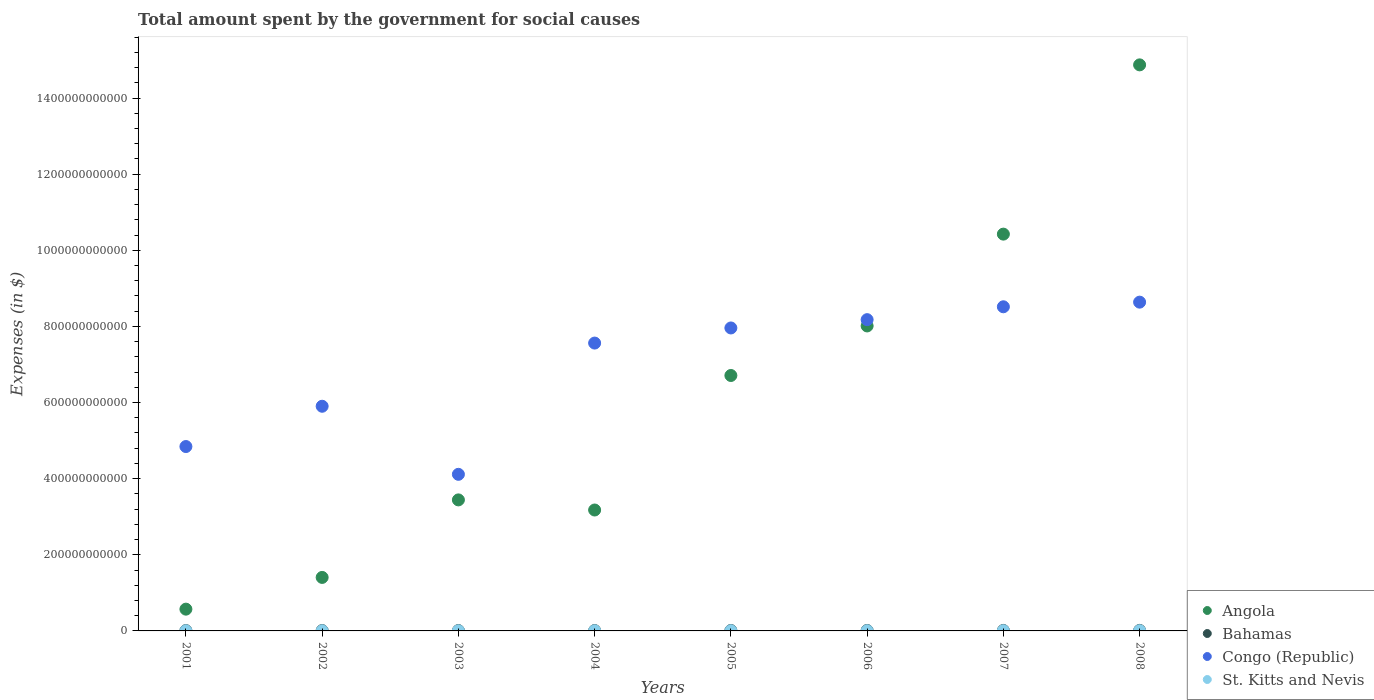Is the number of dotlines equal to the number of legend labels?
Give a very brief answer. Yes. What is the amount spent for social causes by the government in Congo (Republic) in 2007?
Make the answer very short. 8.52e+11. Across all years, what is the maximum amount spent for social causes by the government in St. Kitts and Nevis?
Offer a terse response. 5.36e+08. Across all years, what is the minimum amount spent for social causes by the government in St. Kitts and Nevis?
Your response must be concise. 3.07e+08. What is the total amount spent for social causes by the government in Angola in the graph?
Your response must be concise. 4.86e+12. What is the difference between the amount spent for social causes by the government in St. Kitts and Nevis in 2007 and that in 2008?
Your answer should be very brief. -3.61e+07. What is the difference between the amount spent for social causes by the government in Congo (Republic) in 2007 and the amount spent for social causes by the government in Bahamas in 2008?
Your response must be concise. 8.50e+11. What is the average amount spent for social causes by the government in Bahamas per year?
Your response must be concise. 1.09e+09. In the year 2001, what is the difference between the amount spent for social causes by the government in St. Kitts and Nevis and amount spent for social causes by the government in Congo (Republic)?
Offer a very short reply. -4.84e+11. In how many years, is the amount spent for social causes by the government in Angola greater than 880000000000 $?
Provide a succinct answer. 2. What is the ratio of the amount spent for social causes by the government in Bahamas in 2004 to that in 2007?
Provide a succinct answer. 0.81. Is the amount spent for social causes by the government in Angola in 2001 less than that in 2004?
Your response must be concise. Yes. Is the difference between the amount spent for social causes by the government in St. Kitts and Nevis in 2003 and 2004 greater than the difference between the amount spent for social causes by the government in Congo (Republic) in 2003 and 2004?
Make the answer very short. Yes. What is the difference between the highest and the second highest amount spent for social causes by the government in Angola?
Ensure brevity in your answer.  4.45e+11. What is the difference between the highest and the lowest amount spent for social causes by the government in St. Kitts and Nevis?
Your answer should be compact. 2.29e+08. In how many years, is the amount spent for social causes by the government in St. Kitts and Nevis greater than the average amount spent for social causes by the government in St. Kitts and Nevis taken over all years?
Ensure brevity in your answer.  4. Is the sum of the amount spent for social causes by the government in Bahamas in 2005 and 2006 greater than the maximum amount spent for social causes by the government in Congo (Republic) across all years?
Offer a very short reply. No. Is it the case that in every year, the sum of the amount spent for social causes by the government in Angola and amount spent for social causes by the government in Bahamas  is greater than the sum of amount spent for social causes by the government in Congo (Republic) and amount spent for social causes by the government in St. Kitts and Nevis?
Your answer should be compact. No. Is it the case that in every year, the sum of the amount spent for social causes by the government in St. Kitts and Nevis and amount spent for social causes by the government in Angola  is greater than the amount spent for social causes by the government in Congo (Republic)?
Give a very brief answer. No. Does the amount spent for social causes by the government in Bahamas monotonically increase over the years?
Offer a terse response. Yes. Is the amount spent for social causes by the government in Bahamas strictly greater than the amount spent for social causes by the government in Angola over the years?
Keep it short and to the point. No. How many dotlines are there?
Your response must be concise. 4. What is the difference between two consecutive major ticks on the Y-axis?
Provide a succinct answer. 2.00e+11. Does the graph contain any zero values?
Ensure brevity in your answer.  No. Where does the legend appear in the graph?
Your response must be concise. Bottom right. How many legend labels are there?
Provide a succinct answer. 4. What is the title of the graph?
Offer a very short reply. Total amount spent by the government for social causes. What is the label or title of the Y-axis?
Your answer should be very brief. Expenses (in $). What is the Expenses (in $) in Angola in 2001?
Your response must be concise. 5.72e+1. What is the Expenses (in $) of Bahamas in 2001?
Keep it short and to the point. 8.67e+08. What is the Expenses (in $) of Congo (Republic) in 2001?
Provide a short and direct response. 4.84e+11. What is the Expenses (in $) in St. Kitts and Nevis in 2001?
Your answer should be compact. 3.07e+08. What is the Expenses (in $) in Angola in 2002?
Ensure brevity in your answer.  1.41e+11. What is the Expenses (in $) in Bahamas in 2002?
Provide a succinct answer. 9.23e+08. What is the Expenses (in $) in Congo (Republic) in 2002?
Your response must be concise. 5.90e+11. What is the Expenses (in $) in St. Kitts and Nevis in 2002?
Provide a short and direct response. 3.24e+08. What is the Expenses (in $) in Angola in 2003?
Make the answer very short. 3.44e+11. What is the Expenses (in $) in Bahamas in 2003?
Give a very brief answer. 9.99e+08. What is the Expenses (in $) in Congo (Republic) in 2003?
Your response must be concise. 4.11e+11. What is the Expenses (in $) in St. Kitts and Nevis in 2003?
Your response must be concise. 3.33e+08. What is the Expenses (in $) in Angola in 2004?
Make the answer very short. 3.18e+11. What is the Expenses (in $) of Bahamas in 2004?
Offer a very short reply. 1.02e+09. What is the Expenses (in $) of Congo (Republic) in 2004?
Provide a short and direct response. 7.56e+11. What is the Expenses (in $) in St. Kitts and Nevis in 2004?
Provide a short and direct response. 3.82e+08. What is the Expenses (in $) in Angola in 2005?
Offer a terse response. 6.71e+11. What is the Expenses (in $) in Bahamas in 2005?
Offer a terse response. 1.12e+09. What is the Expenses (in $) of Congo (Republic) in 2005?
Your answer should be very brief. 7.96e+11. What is the Expenses (in $) in St. Kitts and Nevis in 2005?
Give a very brief answer. 4.40e+08. What is the Expenses (in $) of Angola in 2006?
Your answer should be very brief. 8.01e+11. What is the Expenses (in $) of Bahamas in 2006?
Provide a succinct answer. 1.19e+09. What is the Expenses (in $) of Congo (Republic) in 2006?
Your response must be concise. 8.18e+11. What is the Expenses (in $) of St. Kitts and Nevis in 2006?
Offer a very short reply. 4.78e+08. What is the Expenses (in $) in Angola in 2007?
Offer a terse response. 1.04e+12. What is the Expenses (in $) of Bahamas in 2007?
Your answer should be compact. 1.26e+09. What is the Expenses (in $) of Congo (Republic) in 2007?
Make the answer very short. 8.52e+11. What is the Expenses (in $) of St. Kitts and Nevis in 2007?
Give a very brief answer. 5.00e+08. What is the Expenses (in $) of Angola in 2008?
Offer a terse response. 1.49e+12. What is the Expenses (in $) in Bahamas in 2008?
Provide a succinct answer. 1.34e+09. What is the Expenses (in $) in Congo (Republic) in 2008?
Make the answer very short. 8.64e+11. What is the Expenses (in $) in St. Kitts and Nevis in 2008?
Your answer should be compact. 5.36e+08. Across all years, what is the maximum Expenses (in $) in Angola?
Offer a terse response. 1.49e+12. Across all years, what is the maximum Expenses (in $) of Bahamas?
Provide a succinct answer. 1.34e+09. Across all years, what is the maximum Expenses (in $) in Congo (Republic)?
Ensure brevity in your answer.  8.64e+11. Across all years, what is the maximum Expenses (in $) of St. Kitts and Nevis?
Your response must be concise. 5.36e+08. Across all years, what is the minimum Expenses (in $) of Angola?
Ensure brevity in your answer.  5.72e+1. Across all years, what is the minimum Expenses (in $) in Bahamas?
Ensure brevity in your answer.  8.67e+08. Across all years, what is the minimum Expenses (in $) of Congo (Republic)?
Provide a succinct answer. 4.11e+11. Across all years, what is the minimum Expenses (in $) of St. Kitts and Nevis?
Your answer should be very brief. 3.07e+08. What is the total Expenses (in $) of Angola in the graph?
Your response must be concise. 4.86e+12. What is the total Expenses (in $) in Bahamas in the graph?
Your answer should be very brief. 8.72e+09. What is the total Expenses (in $) in Congo (Republic) in the graph?
Your response must be concise. 5.57e+12. What is the total Expenses (in $) in St. Kitts and Nevis in the graph?
Keep it short and to the point. 3.30e+09. What is the difference between the Expenses (in $) of Angola in 2001 and that in 2002?
Provide a succinct answer. -8.34e+1. What is the difference between the Expenses (in $) in Bahamas in 2001 and that in 2002?
Provide a short and direct response. -5.57e+07. What is the difference between the Expenses (in $) in Congo (Republic) in 2001 and that in 2002?
Your answer should be very brief. -1.06e+11. What is the difference between the Expenses (in $) in St. Kitts and Nevis in 2001 and that in 2002?
Ensure brevity in your answer.  -1.65e+07. What is the difference between the Expenses (in $) of Angola in 2001 and that in 2003?
Provide a succinct answer. -2.87e+11. What is the difference between the Expenses (in $) of Bahamas in 2001 and that in 2003?
Your answer should be compact. -1.32e+08. What is the difference between the Expenses (in $) in Congo (Republic) in 2001 and that in 2003?
Make the answer very short. 7.30e+1. What is the difference between the Expenses (in $) in St. Kitts and Nevis in 2001 and that in 2003?
Offer a very short reply. -2.61e+07. What is the difference between the Expenses (in $) in Angola in 2001 and that in 2004?
Your answer should be compact. -2.60e+11. What is the difference between the Expenses (in $) in Bahamas in 2001 and that in 2004?
Give a very brief answer. -1.54e+08. What is the difference between the Expenses (in $) in Congo (Republic) in 2001 and that in 2004?
Ensure brevity in your answer.  -2.72e+11. What is the difference between the Expenses (in $) of St. Kitts and Nevis in 2001 and that in 2004?
Keep it short and to the point. -7.45e+07. What is the difference between the Expenses (in $) of Angola in 2001 and that in 2005?
Offer a very short reply. -6.14e+11. What is the difference between the Expenses (in $) in Bahamas in 2001 and that in 2005?
Your response must be concise. -2.50e+08. What is the difference between the Expenses (in $) of Congo (Republic) in 2001 and that in 2005?
Offer a terse response. -3.12e+11. What is the difference between the Expenses (in $) of St. Kitts and Nevis in 2001 and that in 2005?
Ensure brevity in your answer.  -1.33e+08. What is the difference between the Expenses (in $) of Angola in 2001 and that in 2006?
Keep it short and to the point. -7.44e+11. What is the difference between the Expenses (in $) of Bahamas in 2001 and that in 2006?
Your answer should be very brief. -3.19e+08. What is the difference between the Expenses (in $) in Congo (Republic) in 2001 and that in 2006?
Make the answer very short. -3.33e+11. What is the difference between the Expenses (in $) in St. Kitts and Nevis in 2001 and that in 2006?
Offer a terse response. -1.71e+08. What is the difference between the Expenses (in $) in Angola in 2001 and that in 2007?
Ensure brevity in your answer.  -9.85e+11. What is the difference between the Expenses (in $) of Bahamas in 2001 and that in 2007?
Your response must be concise. -3.93e+08. What is the difference between the Expenses (in $) of Congo (Republic) in 2001 and that in 2007?
Your answer should be very brief. -3.67e+11. What is the difference between the Expenses (in $) of St. Kitts and Nevis in 2001 and that in 2007?
Offer a terse response. -1.93e+08. What is the difference between the Expenses (in $) of Angola in 2001 and that in 2008?
Keep it short and to the point. -1.43e+12. What is the difference between the Expenses (in $) in Bahamas in 2001 and that in 2008?
Give a very brief answer. -4.78e+08. What is the difference between the Expenses (in $) of Congo (Republic) in 2001 and that in 2008?
Offer a terse response. -3.79e+11. What is the difference between the Expenses (in $) of St. Kitts and Nevis in 2001 and that in 2008?
Provide a short and direct response. -2.29e+08. What is the difference between the Expenses (in $) of Angola in 2002 and that in 2003?
Ensure brevity in your answer.  -2.04e+11. What is the difference between the Expenses (in $) of Bahamas in 2002 and that in 2003?
Your answer should be compact. -7.63e+07. What is the difference between the Expenses (in $) in Congo (Republic) in 2002 and that in 2003?
Provide a succinct answer. 1.79e+11. What is the difference between the Expenses (in $) in St. Kitts and Nevis in 2002 and that in 2003?
Give a very brief answer. -9.60e+06. What is the difference between the Expenses (in $) of Angola in 2002 and that in 2004?
Offer a very short reply. -1.77e+11. What is the difference between the Expenses (in $) in Bahamas in 2002 and that in 2004?
Offer a terse response. -9.86e+07. What is the difference between the Expenses (in $) of Congo (Republic) in 2002 and that in 2004?
Provide a short and direct response. -1.66e+11. What is the difference between the Expenses (in $) of St. Kitts and Nevis in 2002 and that in 2004?
Provide a succinct answer. -5.80e+07. What is the difference between the Expenses (in $) of Angola in 2002 and that in 2005?
Offer a terse response. -5.31e+11. What is the difference between the Expenses (in $) of Bahamas in 2002 and that in 2005?
Offer a terse response. -1.94e+08. What is the difference between the Expenses (in $) of Congo (Republic) in 2002 and that in 2005?
Your answer should be very brief. -2.06e+11. What is the difference between the Expenses (in $) of St. Kitts and Nevis in 2002 and that in 2005?
Keep it short and to the point. -1.16e+08. What is the difference between the Expenses (in $) in Angola in 2002 and that in 2006?
Keep it short and to the point. -6.61e+11. What is the difference between the Expenses (in $) in Bahamas in 2002 and that in 2006?
Your answer should be compact. -2.63e+08. What is the difference between the Expenses (in $) of Congo (Republic) in 2002 and that in 2006?
Provide a succinct answer. -2.28e+11. What is the difference between the Expenses (in $) in St. Kitts and Nevis in 2002 and that in 2006?
Offer a terse response. -1.55e+08. What is the difference between the Expenses (in $) in Angola in 2002 and that in 2007?
Keep it short and to the point. -9.02e+11. What is the difference between the Expenses (in $) in Bahamas in 2002 and that in 2007?
Offer a very short reply. -3.37e+08. What is the difference between the Expenses (in $) in Congo (Republic) in 2002 and that in 2007?
Ensure brevity in your answer.  -2.61e+11. What is the difference between the Expenses (in $) in St. Kitts and Nevis in 2002 and that in 2007?
Provide a short and direct response. -1.77e+08. What is the difference between the Expenses (in $) in Angola in 2002 and that in 2008?
Your answer should be very brief. -1.35e+12. What is the difference between the Expenses (in $) in Bahamas in 2002 and that in 2008?
Your answer should be compact. -4.22e+08. What is the difference between the Expenses (in $) in Congo (Republic) in 2002 and that in 2008?
Provide a short and direct response. -2.74e+11. What is the difference between the Expenses (in $) in St. Kitts and Nevis in 2002 and that in 2008?
Offer a terse response. -2.13e+08. What is the difference between the Expenses (in $) of Angola in 2003 and that in 2004?
Your answer should be compact. 2.66e+1. What is the difference between the Expenses (in $) of Bahamas in 2003 and that in 2004?
Ensure brevity in your answer.  -2.23e+07. What is the difference between the Expenses (in $) in Congo (Republic) in 2003 and that in 2004?
Your answer should be very brief. -3.45e+11. What is the difference between the Expenses (in $) of St. Kitts and Nevis in 2003 and that in 2004?
Ensure brevity in your answer.  -4.84e+07. What is the difference between the Expenses (in $) of Angola in 2003 and that in 2005?
Provide a succinct answer. -3.27e+11. What is the difference between the Expenses (in $) in Bahamas in 2003 and that in 2005?
Offer a terse response. -1.18e+08. What is the difference between the Expenses (in $) of Congo (Republic) in 2003 and that in 2005?
Your answer should be very brief. -3.85e+11. What is the difference between the Expenses (in $) of St. Kitts and Nevis in 2003 and that in 2005?
Ensure brevity in your answer.  -1.07e+08. What is the difference between the Expenses (in $) in Angola in 2003 and that in 2006?
Provide a succinct answer. -4.57e+11. What is the difference between the Expenses (in $) of Bahamas in 2003 and that in 2006?
Provide a succinct answer. -1.87e+08. What is the difference between the Expenses (in $) of Congo (Republic) in 2003 and that in 2006?
Provide a short and direct response. -4.06e+11. What is the difference between the Expenses (in $) in St. Kitts and Nevis in 2003 and that in 2006?
Give a very brief answer. -1.45e+08. What is the difference between the Expenses (in $) of Angola in 2003 and that in 2007?
Make the answer very short. -6.98e+11. What is the difference between the Expenses (in $) of Bahamas in 2003 and that in 2007?
Offer a very short reply. -2.61e+08. What is the difference between the Expenses (in $) in Congo (Republic) in 2003 and that in 2007?
Keep it short and to the point. -4.40e+11. What is the difference between the Expenses (in $) in St. Kitts and Nevis in 2003 and that in 2007?
Offer a very short reply. -1.67e+08. What is the difference between the Expenses (in $) in Angola in 2003 and that in 2008?
Give a very brief answer. -1.14e+12. What is the difference between the Expenses (in $) in Bahamas in 2003 and that in 2008?
Your answer should be compact. -3.46e+08. What is the difference between the Expenses (in $) of Congo (Republic) in 2003 and that in 2008?
Ensure brevity in your answer.  -4.52e+11. What is the difference between the Expenses (in $) of St. Kitts and Nevis in 2003 and that in 2008?
Provide a short and direct response. -2.03e+08. What is the difference between the Expenses (in $) in Angola in 2004 and that in 2005?
Provide a succinct answer. -3.53e+11. What is the difference between the Expenses (in $) in Bahamas in 2004 and that in 2005?
Give a very brief answer. -9.59e+07. What is the difference between the Expenses (in $) in Congo (Republic) in 2004 and that in 2005?
Your answer should be very brief. -3.97e+1. What is the difference between the Expenses (in $) in St. Kitts and Nevis in 2004 and that in 2005?
Provide a short and direct response. -5.83e+07. What is the difference between the Expenses (in $) in Angola in 2004 and that in 2006?
Provide a short and direct response. -4.84e+11. What is the difference between the Expenses (in $) in Bahamas in 2004 and that in 2006?
Ensure brevity in your answer.  -1.65e+08. What is the difference between the Expenses (in $) of Congo (Republic) in 2004 and that in 2006?
Give a very brief answer. -6.15e+1. What is the difference between the Expenses (in $) in St. Kitts and Nevis in 2004 and that in 2006?
Your answer should be very brief. -9.67e+07. What is the difference between the Expenses (in $) of Angola in 2004 and that in 2007?
Give a very brief answer. -7.25e+11. What is the difference between the Expenses (in $) in Bahamas in 2004 and that in 2007?
Make the answer very short. -2.39e+08. What is the difference between the Expenses (in $) of Congo (Republic) in 2004 and that in 2007?
Your response must be concise. -9.53e+1. What is the difference between the Expenses (in $) in St. Kitts and Nevis in 2004 and that in 2007?
Offer a very short reply. -1.19e+08. What is the difference between the Expenses (in $) in Angola in 2004 and that in 2008?
Your answer should be very brief. -1.17e+12. What is the difference between the Expenses (in $) of Bahamas in 2004 and that in 2008?
Your response must be concise. -3.24e+08. What is the difference between the Expenses (in $) of Congo (Republic) in 2004 and that in 2008?
Provide a short and direct response. -1.08e+11. What is the difference between the Expenses (in $) in St. Kitts and Nevis in 2004 and that in 2008?
Keep it short and to the point. -1.55e+08. What is the difference between the Expenses (in $) in Angola in 2005 and that in 2006?
Your response must be concise. -1.30e+11. What is the difference between the Expenses (in $) of Bahamas in 2005 and that in 2006?
Give a very brief answer. -6.87e+07. What is the difference between the Expenses (in $) in Congo (Republic) in 2005 and that in 2006?
Keep it short and to the point. -2.18e+1. What is the difference between the Expenses (in $) in St. Kitts and Nevis in 2005 and that in 2006?
Make the answer very short. -3.84e+07. What is the difference between the Expenses (in $) in Angola in 2005 and that in 2007?
Your answer should be very brief. -3.71e+11. What is the difference between the Expenses (in $) in Bahamas in 2005 and that in 2007?
Your answer should be very brief. -1.43e+08. What is the difference between the Expenses (in $) in Congo (Republic) in 2005 and that in 2007?
Give a very brief answer. -5.56e+1. What is the difference between the Expenses (in $) of St. Kitts and Nevis in 2005 and that in 2007?
Ensure brevity in your answer.  -6.03e+07. What is the difference between the Expenses (in $) of Angola in 2005 and that in 2008?
Your response must be concise. -8.16e+11. What is the difference between the Expenses (in $) of Bahamas in 2005 and that in 2008?
Offer a terse response. -2.28e+08. What is the difference between the Expenses (in $) of Congo (Republic) in 2005 and that in 2008?
Ensure brevity in your answer.  -6.78e+1. What is the difference between the Expenses (in $) of St. Kitts and Nevis in 2005 and that in 2008?
Your answer should be very brief. -9.64e+07. What is the difference between the Expenses (in $) in Angola in 2006 and that in 2007?
Your response must be concise. -2.41e+11. What is the difference between the Expenses (in $) of Bahamas in 2006 and that in 2007?
Provide a short and direct response. -7.43e+07. What is the difference between the Expenses (in $) of Congo (Republic) in 2006 and that in 2007?
Offer a terse response. -3.38e+1. What is the difference between the Expenses (in $) of St. Kitts and Nevis in 2006 and that in 2007?
Keep it short and to the point. -2.19e+07. What is the difference between the Expenses (in $) of Angola in 2006 and that in 2008?
Your response must be concise. -6.86e+11. What is the difference between the Expenses (in $) of Bahamas in 2006 and that in 2008?
Offer a very short reply. -1.59e+08. What is the difference between the Expenses (in $) in Congo (Republic) in 2006 and that in 2008?
Your response must be concise. -4.60e+1. What is the difference between the Expenses (in $) in St. Kitts and Nevis in 2006 and that in 2008?
Give a very brief answer. -5.80e+07. What is the difference between the Expenses (in $) of Angola in 2007 and that in 2008?
Give a very brief answer. -4.45e+11. What is the difference between the Expenses (in $) of Bahamas in 2007 and that in 2008?
Offer a very short reply. -8.48e+07. What is the difference between the Expenses (in $) in Congo (Republic) in 2007 and that in 2008?
Your answer should be very brief. -1.22e+1. What is the difference between the Expenses (in $) of St. Kitts and Nevis in 2007 and that in 2008?
Offer a terse response. -3.61e+07. What is the difference between the Expenses (in $) of Angola in 2001 and the Expenses (in $) of Bahamas in 2002?
Make the answer very short. 5.63e+1. What is the difference between the Expenses (in $) of Angola in 2001 and the Expenses (in $) of Congo (Republic) in 2002?
Offer a very short reply. -5.33e+11. What is the difference between the Expenses (in $) in Angola in 2001 and the Expenses (in $) in St. Kitts and Nevis in 2002?
Your response must be concise. 5.69e+1. What is the difference between the Expenses (in $) of Bahamas in 2001 and the Expenses (in $) of Congo (Republic) in 2002?
Ensure brevity in your answer.  -5.89e+11. What is the difference between the Expenses (in $) of Bahamas in 2001 and the Expenses (in $) of St. Kitts and Nevis in 2002?
Keep it short and to the point. 5.44e+08. What is the difference between the Expenses (in $) of Congo (Republic) in 2001 and the Expenses (in $) of St. Kitts and Nevis in 2002?
Keep it short and to the point. 4.84e+11. What is the difference between the Expenses (in $) in Angola in 2001 and the Expenses (in $) in Bahamas in 2003?
Ensure brevity in your answer.  5.62e+1. What is the difference between the Expenses (in $) in Angola in 2001 and the Expenses (in $) in Congo (Republic) in 2003?
Make the answer very short. -3.54e+11. What is the difference between the Expenses (in $) of Angola in 2001 and the Expenses (in $) of St. Kitts and Nevis in 2003?
Ensure brevity in your answer.  5.69e+1. What is the difference between the Expenses (in $) of Bahamas in 2001 and the Expenses (in $) of Congo (Republic) in 2003?
Keep it short and to the point. -4.11e+11. What is the difference between the Expenses (in $) in Bahamas in 2001 and the Expenses (in $) in St. Kitts and Nevis in 2003?
Your answer should be very brief. 5.34e+08. What is the difference between the Expenses (in $) in Congo (Republic) in 2001 and the Expenses (in $) in St. Kitts and Nevis in 2003?
Your answer should be very brief. 4.84e+11. What is the difference between the Expenses (in $) of Angola in 2001 and the Expenses (in $) of Bahamas in 2004?
Offer a very short reply. 5.62e+1. What is the difference between the Expenses (in $) of Angola in 2001 and the Expenses (in $) of Congo (Republic) in 2004?
Offer a terse response. -6.99e+11. What is the difference between the Expenses (in $) of Angola in 2001 and the Expenses (in $) of St. Kitts and Nevis in 2004?
Give a very brief answer. 5.68e+1. What is the difference between the Expenses (in $) of Bahamas in 2001 and the Expenses (in $) of Congo (Republic) in 2004?
Keep it short and to the point. -7.55e+11. What is the difference between the Expenses (in $) in Bahamas in 2001 and the Expenses (in $) in St. Kitts and Nevis in 2004?
Provide a short and direct response. 4.86e+08. What is the difference between the Expenses (in $) of Congo (Republic) in 2001 and the Expenses (in $) of St. Kitts and Nevis in 2004?
Make the answer very short. 4.84e+11. What is the difference between the Expenses (in $) in Angola in 2001 and the Expenses (in $) in Bahamas in 2005?
Your response must be concise. 5.61e+1. What is the difference between the Expenses (in $) of Angola in 2001 and the Expenses (in $) of Congo (Republic) in 2005?
Offer a very short reply. -7.39e+11. What is the difference between the Expenses (in $) of Angola in 2001 and the Expenses (in $) of St. Kitts and Nevis in 2005?
Provide a short and direct response. 5.68e+1. What is the difference between the Expenses (in $) in Bahamas in 2001 and the Expenses (in $) in Congo (Republic) in 2005?
Offer a terse response. -7.95e+11. What is the difference between the Expenses (in $) in Bahamas in 2001 and the Expenses (in $) in St. Kitts and Nevis in 2005?
Offer a very short reply. 4.27e+08. What is the difference between the Expenses (in $) of Congo (Republic) in 2001 and the Expenses (in $) of St. Kitts and Nevis in 2005?
Give a very brief answer. 4.84e+11. What is the difference between the Expenses (in $) in Angola in 2001 and the Expenses (in $) in Bahamas in 2006?
Give a very brief answer. 5.60e+1. What is the difference between the Expenses (in $) in Angola in 2001 and the Expenses (in $) in Congo (Republic) in 2006?
Your answer should be compact. -7.61e+11. What is the difference between the Expenses (in $) of Angola in 2001 and the Expenses (in $) of St. Kitts and Nevis in 2006?
Make the answer very short. 5.67e+1. What is the difference between the Expenses (in $) of Bahamas in 2001 and the Expenses (in $) of Congo (Republic) in 2006?
Make the answer very short. -8.17e+11. What is the difference between the Expenses (in $) of Bahamas in 2001 and the Expenses (in $) of St. Kitts and Nevis in 2006?
Provide a succinct answer. 3.89e+08. What is the difference between the Expenses (in $) in Congo (Republic) in 2001 and the Expenses (in $) in St. Kitts and Nevis in 2006?
Give a very brief answer. 4.84e+11. What is the difference between the Expenses (in $) of Angola in 2001 and the Expenses (in $) of Bahamas in 2007?
Offer a terse response. 5.59e+1. What is the difference between the Expenses (in $) of Angola in 2001 and the Expenses (in $) of Congo (Republic) in 2007?
Keep it short and to the point. -7.94e+11. What is the difference between the Expenses (in $) of Angola in 2001 and the Expenses (in $) of St. Kitts and Nevis in 2007?
Ensure brevity in your answer.  5.67e+1. What is the difference between the Expenses (in $) of Bahamas in 2001 and the Expenses (in $) of Congo (Republic) in 2007?
Give a very brief answer. -8.51e+11. What is the difference between the Expenses (in $) in Bahamas in 2001 and the Expenses (in $) in St. Kitts and Nevis in 2007?
Offer a terse response. 3.67e+08. What is the difference between the Expenses (in $) of Congo (Republic) in 2001 and the Expenses (in $) of St. Kitts and Nevis in 2007?
Offer a terse response. 4.84e+11. What is the difference between the Expenses (in $) of Angola in 2001 and the Expenses (in $) of Bahamas in 2008?
Your answer should be compact. 5.58e+1. What is the difference between the Expenses (in $) of Angola in 2001 and the Expenses (in $) of Congo (Republic) in 2008?
Offer a very short reply. -8.07e+11. What is the difference between the Expenses (in $) in Angola in 2001 and the Expenses (in $) in St. Kitts and Nevis in 2008?
Offer a very short reply. 5.67e+1. What is the difference between the Expenses (in $) of Bahamas in 2001 and the Expenses (in $) of Congo (Republic) in 2008?
Your answer should be compact. -8.63e+11. What is the difference between the Expenses (in $) in Bahamas in 2001 and the Expenses (in $) in St. Kitts and Nevis in 2008?
Make the answer very short. 3.31e+08. What is the difference between the Expenses (in $) of Congo (Republic) in 2001 and the Expenses (in $) of St. Kitts and Nevis in 2008?
Provide a succinct answer. 4.84e+11. What is the difference between the Expenses (in $) in Angola in 2002 and the Expenses (in $) in Bahamas in 2003?
Give a very brief answer. 1.40e+11. What is the difference between the Expenses (in $) in Angola in 2002 and the Expenses (in $) in Congo (Republic) in 2003?
Offer a very short reply. -2.71e+11. What is the difference between the Expenses (in $) in Angola in 2002 and the Expenses (in $) in St. Kitts and Nevis in 2003?
Your answer should be very brief. 1.40e+11. What is the difference between the Expenses (in $) of Bahamas in 2002 and the Expenses (in $) of Congo (Republic) in 2003?
Offer a very short reply. -4.10e+11. What is the difference between the Expenses (in $) in Bahamas in 2002 and the Expenses (in $) in St. Kitts and Nevis in 2003?
Ensure brevity in your answer.  5.90e+08. What is the difference between the Expenses (in $) of Congo (Republic) in 2002 and the Expenses (in $) of St. Kitts and Nevis in 2003?
Make the answer very short. 5.90e+11. What is the difference between the Expenses (in $) in Angola in 2002 and the Expenses (in $) in Bahamas in 2004?
Give a very brief answer. 1.40e+11. What is the difference between the Expenses (in $) of Angola in 2002 and the Expenses (in $) of Congo (Republic) in 2004?
Give a very brief answer. -6.16e+11. What is the difference between the Expenses (in $) of Angola in 2002 and the Expenses (in $) of St. Kitts and Nevis in 2004?
Provide a short and direct response. 1.40e+11. What is the difference between the Expenses (in $) of Bahamas in 2002 and the Expenses (in $) of Congo (Republic) in 2004?
Ensure brevity in your answer.  -7.55e+11. What is the difference between the Expenses (in $) in Bahamas in 2002 and the Expenses (in $) in St. Kitts and Nevis in 2004?
Provide a short and direct response. 5.41e+08. What is the difference between the Expenses (in $) of Congo (Republic) in 2002 and the Expenses (in $) of St. Kitts and Nevis in 2004?
Give a very brief answer. 5.90e+11. What is the difference between the Expenses (in $) in Angola in 2002 and the Expenses (in $) in Bahamas in 2005?
Offer a very short reply. 1.39e+11. What is the difference between the Expenses (in $) of Angola in 2002 and the Expenses (in $) of Congo (Republic) in 2005?
Keep it short and to the point. -6.55e+11. What is the difference between the Expenses (in $) of Angola in 2002 and the Expenses (in $) of St. Kitts and Nevis in 2005?
Offer a terse response. 1.40e+11. What is the difference between the Expenses (in $) of Bahamas in 2002 and the Expenses (in $) of Congo (Republic) in 2005?
Your response must be concise. -7.95e+11. What is the difference between the Expenses (in $) in Bahamas in 2002 and the Expenses (in $) in St. Kitts and Nevis in 2005?
Give a very brief answer. 4.83e+08. What is the difference between the Expenses (in $) in Congo (Republic) in 2002 and the Expenses (in $) in St. Kitts and Nevis in 2005?
Your answer should be compact. 5.90e+11. What is the difference between the Expenses (in $) of Angola in 2002 and the Expenses (in $) of Bahamas in 2006?
Provide a short and direct response. 1.39e+11. What is the difference between the Expenses (in $) of Angola in 2002 and the Expenses (in $) of Congo (Republic) in 2006?
Offer a very short reply. -6.77e+11. What is the difference between the Expenses (in $) in Angola in 2002 and the Expenses (in $) in St. Kitts and Nevis in 2006?
Your response must be concise. 1.40e+11. What is the difference between the Expenses (in $) in Bahamas in 2002 and the Expenses (in $) in Congo (Republic) in 2006?
Make the answer very short. -8.17e+11. What is the difference between the Expenses (in $) in Bahamas in 2002 and the Expenses (in $) in St. Kitts and Nevis in 2006?
Your response must be concise. 4.44e+08. What is the difference between the Expenses (in $) in Congo (Republic) in 2002 and the Expenses (in $) in St. Kitts and Nevis in 2006?
Offer a terse response. 5.90e+11. What is the difference between the Expenses (in $) in Angola in 2002 and the Expenses (in $) in Bahamas in 2007?
Offer a terse response. 1.39e+11. What is the difference between the Expenses (in $) in Angola in 2002 and the Expenses (in $) in Congo (Republic) in 2007?
Provide a short and direct response. -7.11e+11. What is the difference between the Expenses (in $) in Angola in 2002 and the Expenses (in $) in St. Kitts and Nevis in 2007?
Give a very brief answer. 1.40e+11. What is the difference between the Expenses (in $) in Bahamas in 2002 and the Expenses (in $) in Congo (Republic) in 2007?
Your answer should be compact. -8.51e+11. What is the difference between the Expenses (in $) in Bahamas in 2002 and the Expenses (in $) in St. Kitts and Nevis in 2007?
Offer a very short reply. 4.23e+08. What is the difference between the Expenses (in $) in Congo (Republic) in 2002 and the Expenses (in $) in St. Kitts and Nevis in 2007?
Offer a terse response. 5.90e+11. What is the difference between the Expenses (in $) of Angola in 2002 and the Expenses (in $) of Bahamas in 2008?
Keep it short and to the point. 1.39e+11. What is the difference between the Expenses (in $) in Angola in 2002 and the Expenses (in $) in Congo (Republic) in 2008?
Make the answer very short. -7.23e+11. What is the difference between the Expenses (in $) of Angola in 2002 and the Expenses (in $) of St. Kitts and Nevis in 2008?
Provide a short and direct response. 1.40e+11. What is the difference between the Expenses (in $) of Bahamas in 2002 and the Expenses (in $) of Congo (Republic) in 2008?
Offer a terse response. -8.63e+11. What is the difference between the Expenses (in $) of Bahamas in 2002 and the Expenses (in $) of St. Kitts and Nevis in 2008?
Ensure brevity in your answer.  3.86e+08. What is the difference between the Expenses (in $) of Congo (Republic) in 2002 and the Expenses (in $) of St. Kitts and Nevis in 2008?
Your answer should be very brief. 5.90e+11. What is the difference between the Expenses (in $) in Angola in 2003 and the Expenses (in $) in Bahamas in 2004?
Provide a short and direct response. 3.43e+11. What is the difference between the Expenses (in $) of Angola in 2003 and the Expenses (in $) of Congo (Republic) in 2004?
Keep it short and to the point. -4.12e+11. What is the difference between the Expenses (in $) of Angola in 2003 and the Expenses (in $) of St. Kitts and Nevis in 2004?
Give a very brief answer. 3.44e+11. What is the difference between the Expenses (in $) of Bahamas in 2003 and the Expenses (in $) of Congo (Republic) in 2004?
Your answer should be very brief. -7.55e+11. What is the difference between the Expenses (in $) of Bahamas in 2003 and the Expenses (in $) of St. Kitts and Nevis in 2004?
Your answer should be compact. 6.18e+08. What is the difference between the Expenses (in $) of Congo (Republic) in 2003 and the Expenses (in $) of St. Kitts and Nevis in 2004?
Provide a succinct answer. 4.11e+11. What is the difference between the Expenses (in $) in Angola in 2003 and the Expenses (in $) in Bahamas in 2005?
Make the answer very short. 3.43e+11. What is the difference between the Expenses (in $) of Angola in 2003 and the Expenses (in $) of Congo (Republic) in 2005?
Your response must be concise. -4.52e+11. What is the difference between the Expenses (in $) of Angola in 2003 and the Expenses (in $) of St. Kitts and Nevis in 2005?
Offer a very short reply. 3.44e+11. What is the difference between the Expenses (in $) in Bahamas in 2003 and the Expenses (in $) in Congo (Republic) in 2005?
Provide a short and direct response. -7.95e+11. What is the difference between the Expenses (in $) in Bahamas in 2003 and the Expenses (in $) in St. Kitts and Nevis in 2005?
Provide a short and direct response. 5.59e+08. What is the difference between the Expenses (in $) of Congo (Republic) in 2003 and the Expenses (in $) of St. Kitts and Nevis in 2005?
Make the answer very short. 4.11e+11. What is the difference between the Expenses (in $) in Angola in 2003 and the Expenses (in $) in Bahamas in 2006?
Offer a very short reply. 3.43e+11. What is the difference between the Expenses (in $) in Angola in 2003 and the Expenses (in $) in Congo (Republic) in 2006?
Give a very brief answer. -4.74e+11. What is the difference between the Expenses (in $) of Angola in 2003 and the Expenses (in $) of St. Kitts and Nevis in 2006?
Give a very brief answer. 3.44e+11. What is the difference between the Expenses (in $) in Bahamas in 2003 and the Expenses (in $) in Congo (Republic) in 2006?
Ensure brevity in your answer.  -8.17e+11. What is the difference between the Expenses (in $) in Bahamas in 2003 and the Expenses (in $) in St. Kitts and Nevis in 2006?
Make the answer very short. 5.21e+08. What is the difference between the Expenses (in $) of Congo (Republic) in 2003 and the Expenses (in $) of St. Kitts and Nevis in 2006?
Your answer should be very brief. 4.11e+11. What is the difference between the Expenses (in $) of Angola in 2003 and the Expenses (in $) of Bahamas in 2007?
Make the answer very short. 3.43e+11. What is the difference between the Expenses (in $) of Angola in 2003 and the Expenses (in $) of Congo (Republic) in 2007?
Offer a very short reply. -5.07e+11. What is the difference between the Expenses (in $) in Angola in 2003 and the Expenses (in $) in St. Kitts and Nevis in 2007?
Your answer should be compact. 3.44e+11. What is the difference between the Expenses (in $) of Bahamas in 2003 and the Expenses (in $) of Congo (Republic) in 2007?
Give a very brief answer. -8.51e+11. What is the difference between the Expenses (in $) in Bahamas in 2003 and the Expenses (in $) in St. Kitts and Nevis in 2007?
Offer a very short reply. 4.99e+08. What is the difference between the Expenses (in $) in Congo (Republic) in 2003 and the Expenses (in $) in St. Kitts and Nevis in 2007?
Your response must be concise. 4.11e+11. What is the difference between the Expenses (in $) in Angola in 2003 and the Expenses (in $) in Bahamas in 2008?
Keep it short and to the point. 3.43e+11. What is the difference between the Expenses (in $) of Angola in 2003 and the Expenses (in $) of Congo (Republic) in 2008?
Ensure brevity in your answer.  -5.20e+11. What is the difference between the Expenses (in $) in Angola in 2003 and the Expenses (in $) in St. Kitts and Nevis in 2008?
Offer a very short reply. 3.44e+11. What is the difference between the Expenses (in $) in Bahamas in 2003 and the Expenses (in $) in Congo (Republic) in 2008?
Your answer should be very brief. -8.63e+11. What is the difference between the Expenses (in $) in Bahamas in 2003 and the Expenses (in $) in St. Kitts and Nevis in 2008?
Your answer should be very brief. 4.63e+08. What is the difference between the Expenses (in $) in Congo (Republic) in 2003 and the Expenses (in $) in St. Kitts and Nevis in 2008?
Offer a terse response. 4.11e+11. What is the difference between the Expenses (in $) in Angola in 2004 and the Expenses (in $) in Bahamas in 2005?
Offer a very short reply. 3.17e+11. What is the difference between the Expenses (in $) in Angola in 2004 and the Expenses (in $) in Congo (Republic) in 2005?
Your response must be concise. -4.78e+11. What is the difference between the Expenses (in $) of Angola in 2004 and the Expenses (in $) of St. Kitts and Nevis in 2005?
Your answer should be very brief. 3.17e+11. What is the difference between the Expenses (in $) in Bahamas in 2004 and the Expenses (in $) in Congo (Republic) in 2005?
Give a very brief answer. -7.95e+11. What is the difference between the Expenses (in $) in Bahamas in 2004 and the Expenses (in $) in St. Kitts and Nevis in 2005?
Make the answer very short. 5.81e+08. What is the difference between the Expenses (in $) in Congo (Republic) in 2004 and the Expenses (in $) in St. Kitts and Nevis in 2005?
Your answer should be very brief. 7.56e+11. What is the difference between the Expenses (in $) in Angola in 2004 and the Expenses (in $) in Bahamas in 2006?
Your response must be concise. 3.16e+11. What is the difference between the Expenses (in $) of Angola in 2004 and the Expenses (in $) of Congo (Republic) in 2006?
Your response must be concise. -5.00e+11. What is the difference between the Expenses (in $) in Angola in 2004 and the Expenses (in $) in St. Kitts and Nevis in 2006?
Your response must be concise. 3.17e+11. What is the difference between the Expenses (in $) in Bahamas in 2004 and the Expenses (in $) in Congo (Republic) in 2006?
Offer a terse response. -8.17e+11. What is the difference between the Expenses (in $) of Bahamas in 2004 and the Expenses (in $) of St. Kitts and Nevis in 2006?
Your answer should be very brief. 5.43e+08. What is the difference between the Expenses (in $) of Congo (Republic) in 2004 and the Expenses (in $) of St. Kitts and Nevis in 2006?
Offer a very short reply. 7.56e+11. What is the difference between the Expenses (in $) of Angola in 2004 and the Expenses (in $) of Bahamas in 2007?
Keep it short and to the point. 3.16e+11. What is the difference between the Expenses (in $) of Angola in 2004 and the Expenses (in $) of Congo (Republic) in 2007?
Offer a terse response. -5.34e+11. What is the difference between the Expenses (in $) of Angola in 2004 and the Expenses (in $) of St. Kitts and Nevis in 2007?
Offer a terse response. 3.17e+11. What is the difference between the Expenses (in $) of Bahamas in 2004 and the Expenses (in $) of Congo (Republic) in 2007?
Keep it short and to the point. -8.51e+11. What is the difference between the Expenses (in $) in Bahamas in 2004 and the Expenses (in $) in St. Kitts and Nevis in 2007?
Your response must be concise. 5.21e+08. What is the difference between the Expenses (in $) in Congo (Republic) in 2004 and the Expenses (in $) in St. Kitts and Nevis in 2007?
Offer a terse response. 7.56e+11. What is the difference between the Expenses (in $) in Angola in 2004 and the Expenses (in $) in Bahamas in 2008?
Provide a succinct answer. 3.16e+11. What is the difference between the Expenses (in $) of Angola in 2004 and the Expenses (in $) of Congo (Republic) in 2008?
Offer a very short reply. -5.46e+11. What is the difference between the Expenses (in $) in Angola in 2004 and the Expenses (in $) in St. Kitts and Nevis in 2008?
Make the answer very short. 3.17e+11. What is the difference between the Expenses (in $) of Bahamas in 2004 and the Expenses (in $) of Congo (Republic) in 2008?
Your answer should be very brief. -8.63e+11. What is the difference between the Expenses (in $) of Bahamas in 2004 and the Expenses (in $) of St. Kitts and Nevis in 2008?
Your response must be concise. 4.85e+08. What is the difference between the Expenses (in $) in Congo (Republic) in 2004 and the Expenses (in $) in St. Kitts and Nevis in 2008?
Ensure brevity in your answer.  7.56e+11. What is the difference between the Expenses (in $) in Angola in 2005 and the Expenses (in $) in Bahamas in 2006?
Keep it short and to the point. 6.70e+11. What is the difference between the Expenses (in $) of Angola in 2005 and the Expenses (in $) of Congo (Republic) in 2006?
Offer a terse response. -1.47e+11. What is the difference between the Expenses (in $) in Angola in 2005 and the Expenses (in $) in St. Kitts and Nevis in 2006?
Offer a very short reply. 6.71e+11. What is the difference between the Expenses (in $) of Bahamas in 2005 and the Expenses (in $) of Congo (Republic) in 2006?
Keep it short and to the point. -8.17e+11. What is the difference between the Expenses (in $) in Bahamas in 2005 and the Expenses (in $) in St. Kitts and Nevis in 2006?
Your answer should be compact. 6.39e+08. What is the difference between the Expenses (in $) of Congo (Republic) in 2005 and the Expenses (in $) of St. Kitts and Nevis in 2006?
Offer a very short reply. 7.95e+11. What is the difference between the Expenses (in $) of Angola in 2005 and the Expenses (in $) of Bahamas in 2007?
Provide a succinct answer. 6.70e+11. What is the difference between the Expenses (in $) in Angola in 2005 and the Expenses (in $) in Congo (Republic) in 2007?
Provide a succinct answer. -1.81e+11. What is the difference between the Expenses (in $) in Angola in 2005 and the Expenses (in $) in St. Kitts and Nevis in 2007?
Offer a terse response. 6.71e+11. What is the difference between the Expenses (in $) of Bahamas in 2005 and the Expenses (in $) of Congo (Republic) in 2007?
Provide a succinct answer. -8.50e+11. What is the difference between the Expenses (in $) in Bahamas in 2005 and the Expenses (in $) in St. Kitts and Nevis in 2007?
Keep it short and to the point. 6.17e+08. What is the difference between the Expenses (in $) in Congo (Republic) in 2005 and the Expenses (in $) in St. Kitts and Nevis in 2007?
Give a very brief answer. 7.95e+11. What is the difference between the Expenses (in $) in Angola in 2005 and the Expenses (in $) in Bahamas in 2008?
Offer a terse response. 6.70e+11. What is the difference between the Expenses (in $) in Angola in 2005 and the Expenses (in $) in Congo (Republic) in 2008?
Make the answer very short. -1.93e+11. What is the difference between the Expenses (in $) in Angola in 2005 and the Expenses (in $) in St. Kitts and Nevis in 2008?
Provide a succinct answer. 6.71e+11. What is the difference between the Expenses (in $) in Bahamas in 2005 and the Expenses (in $) in Congo (Republic) in 2008?
Offer a very short reply. -8.63e+11. What is the difference between the Expenses (in $) of Bahamas in 2005 and the Expenses (in $) of St. Kitts and Nevis in 2008?
Provide a succinct answer. 5.81e+08. What is the difference between the Expenses (in $) in Congo (Republic) in 2005 and the Expenses (in $) in St. Kitts and Nevis in 2008?
Offer a very short reply. 7.95e+11. What is the difference between the Expenses (in $) in Angola in 2006 and the Expenses (in $) in Bahamas in 2007?
Give a very brief answer. 8.00e+11. What is the difference between the Expenses (in $) of Angola in 2006 and the Expenses (in $) of Congo (Republic) in 2007?
Offer a terse response. -5.03e+1. What is the difference between the Expenses (in $) of Angola in 2006 and the Expenses (in $) of St. Kitts and Nevis in 2007?
Keep it short and to the point. 8.01e+11. What is the difference between the Expenses (in $) in Bahamas in 2006 and the Expenses (in $) in Congo (Republic) in 2007?
Offer a terse response. -8.50e+11. What is the difference between the Expenses (in $) in Bahamas in 2006 and the Expenses (in $) in St. Kitts and Nevis in 2007?
Keep it short and to the point. 6.86e+08. What is the difference between the Expenses (in $) in Congo (Republic) in 2006 and the Expenses (in $) in St. Kitts and Nevis in 2007?
Offer a terse response. 8.17e+11. What is the difference between the Expenses (in $) of Angola in 2006 and the Expenses (in $) of Bahamas in 2008?
Provide a succinct answer. 8.00e+11. What is the difference between the Expenses (in $) of Angola in 2006 and the Expenses (in $) of Congo (Republic) in 2008?
Your answer should be very brief. -6.25e+1. What is the difference between the Expenses (in $) in Angola in 2006 and the Expenses (in $) in St. Kitts and Nevis in 2008?
Your answer should be compact. 8.01e+11. What is the difference between the Expenses (in $) in Bahamas in 2006 and the Expenses (in $) in Congo (Republic) in 2008?
Make the answer very short. -8.63e+11. What is the difference between the Expenses (in $) of Bahamas in 2006 and the Expenses (in $) of St. Kitts and Nevis in 2008?
Offer a terse response. 6.50e+08. What is the difference between the Expenses (in $) of Congo (Republic) in 2006 and the Expenses (in $) of St. Kitts and Nevis in 2008?
Ensure brevity in your answer.  8.17e+11. What is the difference between the Expenses (in $) in Angola in 2007 and the Expenses (in $) in Bahamas in 2008?
Provide a short and direct response. 1.04e+12. What is the difference between the Expenses (in $) of Angola in 2007 and the Expenses (in $) of Congo (Republic) in 2008?
Provide a succinct answer. 1.79e+11. What is the difference between the Expenses (in $) in Angola in 2007 and the Expenses (in $) in St. Kitts and Nevis in 2008?
Provide a short and direct response. 1.04e+12. What is the difference between the Expenses (in $) in Bahamas in 2007 and the Expenses (in $) in Congo (Republic) in 2008?
Make the answer very short. -8.63e+11. What is the difference between the Expenses (in $) in Bahamas in 2007 and the Expenses (in $) in St. Kitts and Nevis in 2008?
Make the answer very short. 7.24e+08. What is the difference between the Expenses (in $) of Congo (Republic) in 2007 and the Expenses (in $) of St. Kitts and Nevis in 2008?
Ensure brevity in your answer.  8.51e+11. What is the average Expenses (in $) of Angola per year?
Make the answer very short. 6.08e+11. What is the average Expenses (in $) in Bahamas per year?
Provide a succinct answer. 1.09e+09. What is the average Expenses (in $) of Congo (Republic) per year?
Your answer should be very brief. 6.96e+11. What is the average Expenses (in $) of St. Kitts and Nevis per year?
Keep it short and to the point. 4.12e+08. In the year 2001, what is the difference between the Expenses (in $) of Angola and Expenses (in $) of Bahamas?
Give a very brief answer. 5.63e+1. In the year 2001, what is the difference between the Expenses (in $) of Angola and Expenses (in $) of Congo (Republic)?
Provide a short and direct response. -4.27e+11. In the year 2001, what is the difference between the Expenses (in $) in Angola and Expenses (in $) in St. Kitts and Nevis?
Offer a very short reply. 5.69e+1. In the year 2001, what is the difference between the Expenses (in $) in Bahamas and Expenses (in $) in Congo (Republic)?
Offer a very short reply. -4.84e+11. In the year 2001, what is the difference between the Expenses (in $) of Bahamas and Expenses (in $) of St. Kitts and Nevis?
Give a very brief answer. 5.60e+08. In the year 2001, what is the difference between the Expenses (in $) of Congo (Republic) and Expenses (in $) of St. Kitts and Nevis?
Offer a terse response. 4.84e+11. In the year 2002, what is the difference between the Expenses (in $) of Angola and Expenses (in $) of Bahamas?
Ensure brevity in your answer.  1.40e+11. In the year 2002, what is the difference between the Expenses (in $) in Angola and Expenses (in $) in Congo (Republic)?
Offer a very short reply. -4.50e+11. In the year 2002, what is the difference between the Expenses (in $) of Angola and Expenses (in $) of St. Kitts and Nevis?
Give a very brief answer. 1.40e+11. In the year 2002, what is the difference between the Expenses (in $) in Bahamas and Expenses (in $) in Congo (Republic)?
Ensure brevity in your answer.  -5.89e+11. In the year 2002, what is the difference between the Expenses (in $) of Bahamas and Expenses (in $) of St. Kitts and Nevis?
Your answer should be very brief. 5.99e+08. In the year 2002, what is the difference between the Expenses (in $) in Congo (Republic) and Expenses (in $) in St. Kitts and Nevis?
Make the answer very short. 5.90e+11. In the year 2003, what is the difference between the Expenses (in $) in Angola and Expenses (in $) in Bahamas?
Offer a very short reply. 3.43e+11. In the year 2003, what is the difference between the Expenses (in $) of Angola and Expenses (in $) of Congo (Republic)?
Offer a very short reply. -6.72e+1. In the year 2003, what is the difference between the Expenses (in $) of Angola and Expenses (in $) of St. Kitts and Nevis?
Your answer should be compact. 3.44e+11. In the year 2003, what is the difference between the Expenses (in $) in Bahamas and Expenses (in $) in Congo (Republic)?
Give a very brief answer. -4.10e+11. In the year 2003, what is the difference between the Expenses (in $) of Bahamas and Expenses (in $) of St. Kitts and Nevis?
Provide a short and direct response. 6.66e+08. In the year 2003, what is the difference between the Expenses (in $) in Congo (Republic) and Expenses (in $) in St. Kitts and Nevis?
Offer a very short reply. 4.11e+11. In the year 2004, what is the difference between the Expenses (in $) in Angola and Expenses (in $) in Bahamas?
Your response must be concise. 3.17e+11. In the year 2004, what is the difference between the Expenses (in $) in Angola and Expenses (in $) in Congo (Republic)?
Provide a succinct answer. -4.39e+11. In the year 2004, what is the difference between the Expenses (in $) in Angola and Expenses (in $) in St. Kitts and Nevis?
Provide a succinct answer. 3.17e+11. In the year 2004, what is the difference between the Expenses (in $) of Bahamas and Expenses (in $) of Congo (Republic)?
Your answer should be very brief. -7.55e+11. In the year 2004, what is the difference between the Expenses (in $) in Bahamas and Expenses (in $) in St. Kitts and Nevis?
Provide a short and direct response. 6.40e+08. In the year 2004, what is the difference between the Expenses (in $) of Congo (Republic) and Expenses (in $) of St. Kitts and Nevis?
Ensure brevity in your answer.  7.56e+11. In the year 2005, what is the difference between the Expenses (in $) in Angola and Expenses (in $) in Bahamas?
Ensure brevity in your answer.  6.70e+11. In the year 2005, what is the difference between the Expenses (in $) of Angola and Expenses (in $) of Congo (Republic)?
Your answer should be compact. -1.25e+11. In the year 2005, what is the difference between the Expenses (in $) in Angola and Expenses (in $) in St. Kitts and Nevis?
Offer a terse response. 6.71e+11. In the year 2005, what is the difference between the Expenses (in $) of Bahamas and Expenses (in $) of Congo (Republic)?
Offer a very short reply. -7.95e+11. In the year 2005, what is the difference between the Expenses (in $) of Bahamas and Expenses (in $) of St. Kitts and Nevis?
Your answer should be very brief. 6.77e+08. In the year 2005, what is the difference between the Expenses (in $) in Congo (Republic) and Expenses (in $) in St. Kitts and Nevis?
Your response must be concise. 7.96e+11. In the year 2006, what is the difference between the Expenses (in $) in Angola and Expenses (in $) in Bahamas?
Keep it short and to the point. 8.00e+11. In the year 2006, what is the difference between the Expenses (in $) of Angola and Expenses (in $) of Congo (Republic)?
Keep it short and to the point. -1.65e+1. In the year 2006, what is the difference between the Expenses (in $) in Angola and Expenses (in $) in St. Kitts and Nevis?
Make the answer very short. 8.01e+11. In the year 2006, what is the difference between the Expenses (in $) in Bahamas and Expenses (in $) in Congo (Republic)?
Your response must be concise. -8.17e+11. In the year 2006, what is the difference between the Expenses (in $) of Bahamas and Expenses (in $) of St. Kitts and Nevis?
Keep it short and to the point. 7.08e+08. In the year 2006, what is the difference between the Expenses (in $) of Congo (Republic) and Expenses (in $) of St. Kitts and Nevis?
Provide a short and direct response. 8.17e+11. In the year 2007, what is the difference between the Expenses (in $) of Angola and Expenses (in $) of Bahamas?
Offer a very short reply. 1.04e+12. In the year 2007, what is the difference between the Expenses (in $) of Angola and Expenses (in $) of Congo (Republic)?
Your response must be concise. 1.91e+11. In the year 2007, what is the difference between the Expenses (in $) in Angola and Expenses (in $) in St. Kitts and Nevis?
Make the answer very short. 1.04e+12. In the year 2007, what is the difference between the Expenses (in $) in Bahamas and Expenses (in $) in Congo (Republic)?
Give a very brief answer. -8.50e+11. In the year 2007, what is the difference between the Expenses (in $) in Bahamas and Expenses (in $) in St. Kitts and Nevis?
Ensure brevity in your answer.  7.60e+08. In the year 2007, what is the difference between the Expenses (in $) in Congo (Republic) and Expenses (in $) in St. Kitts and Nevis?
Give a very brief answer. 8.51e+11. In the year 2008, what is the difference between the Expenses (in $) in Angola and Expenses (in $) in Bahamas?
Provide a succinct answer. 1.49e+12. In the year 2008, what is the difference between the Expenses (in $) in Angola and Expenses (in $) in Congo (Republic)?
Make the answer very short. 6.23e+11. In the year 2008, what is the difference between the Expenses (in $) in Angola and Expenses (in $) in St. Kitts and Nevis?
Make the answer very short. 1.49e+12. In the year 2008, what is the difference between the Expenses (in $) of Bahamas and Expenses (in $) of Congo (Republic)?
Your answer should be very brief. -8.62e+11. In the year 2008, what is the difference between the Expenses (in $) of Bahamas and Expenses (in $) of St. Kitts and Nevis?
Your response must be concise. 8.09e+08. In the year 2008, what is the difference between the Expenses (in $) in Congo (Republic) and Expenses (in $) in St. Kitts and Nevis?
Provide a short and direct response. 8.63e+11. What is the ratio of the Expenses (in $) of Angola in 2001 to that in 2002?
Provide a short and direct response. 0.41. What is the ratio of the Expenses (in $) in Bahamas in 2001 to that in 2002?
Your response must be concise. 0.94. What is the ratio of the Expenses (in $) in Congo (Republic) in 2001 to that in 2002?
Your answer should be very brief. 0.82. What is the ratio of the Expenses (in $) in St. Kitts and Nevis in 2001 to that in 2002?
Offer a terse response. 0.95. What is the ratio of the Expenses (in $) in Angola in 2001 to that in 2003?
Offer a very short reply. 0.17. What is the ratio of the Expenses (in $) of Bahamas in 2001 to that in 2003?
Offer a terse response. 0.87. What is the ratio of the Expenses (in $) of Congo (Republic) in 2001 to that in 2003?
Offer a very short reply. 1.18. What is the ratio of the Expenses (in $) in St. Kitts and Nevis in 2001 to that in 2003?
Offer a terse response. 0.92. What is the ratio of the Expenses (in $) in Angola in 2001 to that in 2004?
Make the answer very short. 0.18. What is the ratio of the Expenses (in $) in Bahamas in 2001 to that in 2004?
Offer a very short reply. 0.85. What is the ratio of the Expenses (in $) in Congo (Republic) in 2001 to that in 2004?
Offer a terse response. 0.64. What is the ratio of the Expenses (in $) of St. Kitts and Nevis in 2001 to that in 2004?
Your response must be concise. 0.8. What is the ratio of the Expenses (in $) in Angola in 2001 to that in 2005?
Provide a succinct answer. 0.09. What is the ratio of the Expenses (in $) in Bahamas in 2001 to that in 2005?
Your answer should be very brief. 0.78. What is the ratio of the Expenses (in $) of Congo (Republic) in 2001 to that in 2005?
Ensure brevity in your answer.  0.61. What is the ratio of the Expenses (in $) in St. Kitts and Nevis in 2001 to that in 2005?
Offer a very short reply. 0.7. What is the ratio of the Expenses (in $) in Angola in 2001 to that in 2006?
Offer a very short reply. 0.07. What is the ratio of the Expenses (in $) in Bahamas in 2001 to that in 2006?
Your answer should be very brief. 0.73. What is the ratio of the Expenses (in $) of Congo (Republic) in 2001 to that in 2006?
Offer a very short reply. 0.59. What is the ratio of the Expenses (in $) in St. Kitts and Nevis in 2001 to that in 2006?
Give a very brief answer. 0.64. What is the ratio of the Expenses (in $) of Angola in 2001 to that in 2007?
Offer a very short reply. 0.05. What is the ratio of the Expenses (in $) in Bahamas in 2001 to that in 2007?
Provide a short and direct response. 0.69. What is the ratio of the Expenses (in $) in Congo (Republic) in 2001 to that in 2007?
Provide a succinct answer. 0.57. What is the ratio of the Expenses (in $) in St. Kitts and Nevis in 2001 to that in 2007?
Your answer should be compact. 0.61. What is the ratio of the Expenses (in $) in Angola in 2001 to that in 2008?
Ensure brevity in your answer.  0.04. What is the ratio of the Expenses (in $) in Bahamas in 2001 to that in 2008?
Your answer should be very brief. 0.64. What is the ratio of the Expenses (in $) in Congo (Republic) in 2001 to that in 2008?
Give a very brief answer. 0.56. What is the ratio of the Expenses (in $) in St. Kitts and Nevis in 2001 to that in 2008?
Offer a very short reply. 0.57. What is the ratio of the Expenses (in $) of Angola in 2002 to that in 2003?
Offer a terse response. 0.41. What is the ratio of the Expenses (in $) of Bahamas in 2002 to that in 2003?
Make the answer very short. 0.92. What is the ratio of the Expenses (in $) of Congo (Republic) in 2002 to that in 2003?
Offer a terse response. 1.43. What is the ratio of the Expenses (in $) of St. Kitts and Nevis in 2002 to that in 2003?
Provide a short and direct response. 0.97. What is the ratio of the Expenses (in $) of Angola in 2002 to that in 2004?
Your answer should be compact. 0.44. What is the ratio of the Expenses (in $) in Bahamas in 2002 to that in 2004?
Your response must be concise. 0.9. What is the ratio of the Expenses (in $) of Congo (Republic) in 2002 to that in 2004?
Keep it short and to the point. 0.78. What is the ratio of the Expenses (in $) of St. Kitts and Nevis in 2002 to that in 2004?
Your answer should be very brief. 0.85. What is the ratio of the Expenses (in $) of Angola in 2002 to that in 2005?
Offer a terse response. 0.21. What is the ratio of the Expenses (in $) of Bahamas in 2002 to that in 2005?
Ensure brevity in your answer.  0.83. What is the ratio of the Expenses (in $) of Congo (Republic) in 2002 to that in 2005?
Offer a very short reply. 0.74. What is the ratio of the Expenses (in $) of St. Kitts and Nevis in 2002 to that in 2005?
Offer a terse response. 0.74. What is the ratio of the Expenses (in $) in Angola in 2002 to that in 2006?
Your response must be concise. 0.18. What is the ratio of the Expenses (in $) in Bahamas in 2002 to that in 2006?
Offer a terse response. 0.78. What is the ratio of the Expenses (in $) in Congo (Republic) in 2002 to that in 2006?
Provide a short and direct response. 0.72. What is the ratio of the Expenses (in $) in St. Kitts and Nevis in 2002 to that in 2006?
Offer a terse response. 0.68. What is the ratio of the Expenses (in $) in Angola in 2002 to that in 2007?
Your response must be concise. 0.13. What is the ratio of the Expenses (in $) of Bahamas in 2002 to that in 2007?
Make the answer very short. 0.73. What is the ratio of the Expenses (in $) in Congo (Republic) in 2002 to that in 2007?
Keep it short and to the point. 0.69. What is the ratio of the Expenses (in $) in St. Kitts and Nevis in 2002 to that in 2007?
Make the answer very short. 0.65. What is the ratio of the Expenses (in $) in Angola in 2002 to that in 2008?
Offer a very short reply. 0.09. What is the ratio of the Expenses (in $) in Bahamas in 2002 to that in 2008?
Your answer should be compact. 0.69. What is the ratio of the Expenses (in $) of Congo (Republic) in 2002 to that in 2008?
Your response must be concise. 0.68. What is the ratio of the Expenses (in $) in St. Kitts and Nevis in 2002 to that in 2008?
Keep it short and to the point. 0.6. What is the ratio of the Expenses (in $) of Angola in 2003 to that in 2004?
Ensure brevity in your answer.  1.08. What is the ratio of the Expenses (in $) in Bahamas in 2003 to that in 2004?
Offer a terse response. 0.98. What is the ratio of the Expenses (in $) of Congo (Republic) in 2003 to that in 2004?
Ensure brevity in your answer.  0.54. What is the ratio of the Expenses (in $) of St. Kitts and Nevis in 2003 to that in 2004?
Ensure brevity in your answer.  0.87. What is the ratio of the Expenses (in $) of Angola in 2003 to that in 2005?
Offer a very short reply. 0.51. What is the ratio of the Expenses (in $) of Bahamas in 2003 to that in 2005?
Offer a terse response. 0.89. What is the ratio of the Expenses (in $) of Congo (Republic) in 2003 to that in 2005?
Your answer should be compact. 0.52. What is the ratio of the Expenses (in $) in St. Kitts and Nevis in 2003 to that in 2005?
Offer a very short reply. 0.76. What is the ratio of the Expenses (in $) of Angola in 2003 to that in 2006?
Offer a terse response. 0.43. What is the ratio of the Expenses (in $) in Bahamas in 2003 to that in 2006?
Offer a terse response. 0.84. What is the ratio of the Expenses (in $) of Congo (Republic) in 2003 to that in 2006?
Provide a short and direct response. 0.5. What is the ratio of the Expenses (in $) of St. Kitts and Nevis in 2003 to that in 2006?
Make the answer very short. 0.7. What is the ratio of the Expenses (in $) of Angola in 2003 to that in 2007?
Offer a terse response. 0.33. What is the ratio of the Expenses (in $) in Bahamas in 2003 to that in 2007?
Keep it short and to the point. 0.79. What is the ratio of the Expenses (in $) in Congo (Republic) in 2003 to that in 2007?
Make the answer very short. 0.48. What is the ratio of the Expenses (in $) in St. Kitts and Nevis in 2003 to that in 2007?
Give a very brief answer. 0.67. What is the ratio of the Expenses (in $) in Angola in 2003 to that in 2008?
Keep it short and to the point. 0.23. What is the ratio of the Expenses (in $) of Bahamas in 2003 to that in 2008?
Provide a succinct answer. 0.74. What is the ratio of the Expenses (in $) in Congo (Republic) in 2003 to that in 2008?
Your answer should be compact. 0.48. What is the ratio of the Expenses (in $) of St. Kitts and Nevis in 2003 to that in 2008?
Your response must be concise. 0.62. What is the ratio of the Expenses (in $) in Angola in 2004 to that in 2005?
Ensure brevity in your answer.  0.47. What is the ratio of the Expenses (in $) in Bahamas in 2004 to that in 2005?
Ensure brevity in your answer.  0.91. What is the ratio of the Expenses (in $) of Congo (Republic) in 2004 to that in 2005?
Make the answer very short. 0.95. What is the ratio of the Expenses (in $) in St. Kitts and Nevis in 2004 to that in 2005?
Ensure brevity in your answer.  0.87. What is the ratio of the Expenses (in $) in Angola in 2004 to that in 2006?
Offer a terse response. 0.4. What is the ratio of the Expenses (in $) of Bahamas in 2004 to that in 2006?
Your answer should be compact. 0.86. What is the ratio of the Expenses (in $) in Congo (Republic) in 2004 to that in 2006?
Give a very brief answer. 0.92. What is the ratio of the Expenses (in $) of St. Kitts and Nevis in 2004 to that in 2006?
Your response must be concise. 0.8. What is the ratio of the Expenses (in $) in Angola in 2004 to that in 2007?
Your answer should be very brief. 0.3. What is the ratio of the Expenses (in $) of Bahamas in 2004 to that in 2007?
Provide a succinct answer. 0.81. What is the ratio of the Expenses (in $) in Congo (Republic) in 2004 to that in 2007?
Give a very brief answer. 0.89. What is the ratio of the Expenses (in $) in St. Kitts and Nevis in 2004 to that in 2007?
Provide a short and direct response. 0.76. What is the ratio of the Expenses (in $) of Angola in 2004 to that in 2008?
Provide a short and direct response. 0.21. What is the ratio of the Expenses (in $) in Bahamas in 2004 to that in 2008?
Your response must be concise. 0.76. What is the ratio of the Expenses (in $) in Congo (Republic) in 2004 to that in 2008?
Keep it short and to the point. 0.88. What is the ratio of the Expenses (in $) in St. Kitts and Nevis in 2004 to that in 2008?
Your answer should be very brief. 0.71. What is the ratio of the Expenses (in $) of Angola in 2005 to that in 2006?
Provide a short and direct response. 0.84. What is the ratio of the Expenses (in $) in Bahamas in 2005 to that in 2006?
Offer a terse response. 0.94. What is the ratio of the Expenses (in $) of Congo (Republic) in 2005 to that in 2006?
Offer a very short reply. 0.97. What is the ratio of the Expenses (in $) in St. Kitts and Nevis in 2005 to that in 2006?
Make the answer very short. 0.92. What is the ratio of the Expenses (in $) of Angola in 2005 to that in 2007?
Ensure brevity in your answer.  0.64. What is the ratio of the Expenses (in $) of Bahamas in 2005 to that in 2007?
Your answer should be compact. 0.89. What is the ratio of the Expenses (in $) of Congo (Republic) in 2005 to that in 2007?
Provide a short and direct response. 0.93. What is the ratio of the Expenses (in $) of St. Kitts and Nevis in 2005 to that in 2007?
Offer a very short reply. 0.88. What is the ratio of the Expenses (in $) in Angola in 2005 to that in 2008?
Make the answer very short. 0.45. What is the ratio of the Expenses (in $) in Bahamas in 2005 to that in 2008?
Ensure brevity in your answer.  0.83. What is the ratio of the Expenses (in $) in Congo (Republic) in 2005 to that in 2008?
Your answer should be compact. 0.92. What is the ratio of the Expenses (in $) in St. Kitts and Nevis in 2005 to that in 2008?
Offer a terse response. 0.82. What is the ratio of the Expenses (in $) in Angola in 2006 to that in 2007?
Keep it short and to the point. 0.77. What is the ratio of the Expenses (in $) of Bahamas in 2006 to that in 2007?
Ensure brevity in your answer.  0.94. What is the ratio of the Expenses (in $) of Congo (Republic) in 2006 to that in 2007?
Your answer should be compact. 0.96. What is the ratio of the Expenses (in $) of St. Kitts and Nevis in 2006 to that in 2007?
Provide a short and direct response. 0.96. What is the ratio of the Expenses (in $) of Angola in 2006 to that in 2008?
Your answer should be very brief. 0.54. What is the ratio of the Expenses (in $) of Bahamas in 2006 to that in 2008?
Ensure brevity in your answer.  0.88. What is the ratio of the Expenses (in $) of Congo (Republic) in 2006 to that in 2008?
Your response must be concise. 0.95. What is the ratio of the Expenses (in $) in St. Kitts and Nevis in 2006 to that in 2008?
Offer a very short reply. 0.89. What is the ratio of the Expenses (in $) of Angola in 2007 to that in 2008?
Keep it short and to the point. 0.7. What is the ratio of the Expenses (in $) in Bahamas in 2007 to that in 2008?
Provide a succinct answer. 0.94. What is the ratio of the Expenses (in $) of Congo (Republic) in 2007 to that in 2008?
Keep it short and to the point. 0.99. What is the ratio of the Expenses (in $) in St. Kitts and Nevis in 2007 to that in 2008?
Give a very brief answer. 0.93. What is the difference between the highest and the second highest Expenses (in $) of Angola?
Your answer should be compact. 4.45e+11. What is the difference between the highest and the second highest Expenses (in $) of Bahamas?
Offer a very short reply. 8.48e+07. What is the difference between the highest and the second highest Expenses (in $) of Congo (Republic)?
Make the answer very short. 1.22e+1. What is the difference between the highest and the second highest Expenses (in $) in St. Kitts and Nevis?
Provide a short and direct response. 3.61e+07. What is the difference between the highest and the lowest Expenses (in $) of Angola?
Make the answer very short. 1.43e+12. What is the difference between the highest and the lowest Expenses (in $) in Bahamas?
Keep it short and to the point. 4.78e+08. What is the difference between the highest and the lowest Expenses (in $) in Congo (Republic)?
Offer a very short reply. 4.52e+11. What is the difference between the highest and the lowest Expenses (in $) in St. Kitts and Nevis?
Your answer should be very brief. 2.29e+08. 